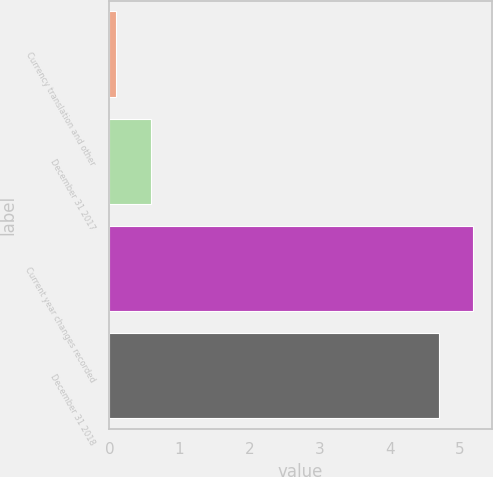<chart> <loc_0><loc_0><loc_500><loc_500><bar_chart><fcel>Currency translation and other<fcel>December 31 2017<fcel>Current year changes recorded<fcel>December 31 2018<nl><fcel>0.1<fcel>0.59<fcel>5.19<fcel>4.7<nl></chart> 